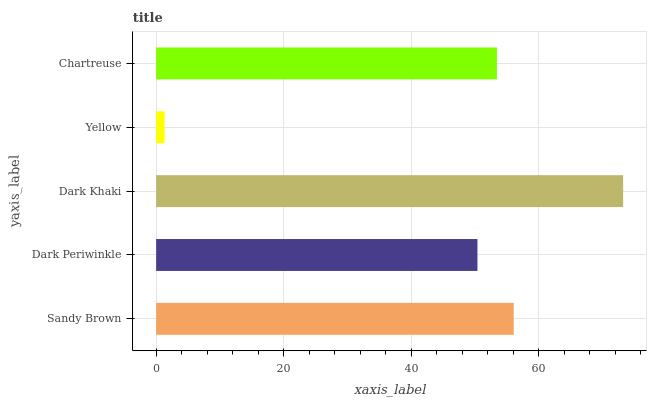Is Yellow the minimum?
Answer yes or no. Yes. Is Dark Khaki the maximum?
Answer yes or no. Yes. Is Dark Periwinkle the minimum?
Answer yes or no. No. Is Dark Periwinkle the maximum?
Answer yes or no. No. Is Sandy Brown greater than Dark Periwinkle?
Answer yes or no. Yes. Is Dark Periwinkle less than Sandy Brown?
Answer yes or no. Yes. Is Dark Periwinkle greater than Sandy Brown?
Answer yes or no. No. Is Sandy Brown less than Dark Periwinkle?
Answer yes or no. No. Is Chartreuse the high median?
Answer yes or no. Yes. Is Chartreuse the low median?
Answer yes or no. Yes. Is Dark Periwinkle the high median?
Answer yes or no. No. Is Yellow the low median?
Answer yes or no. No. 